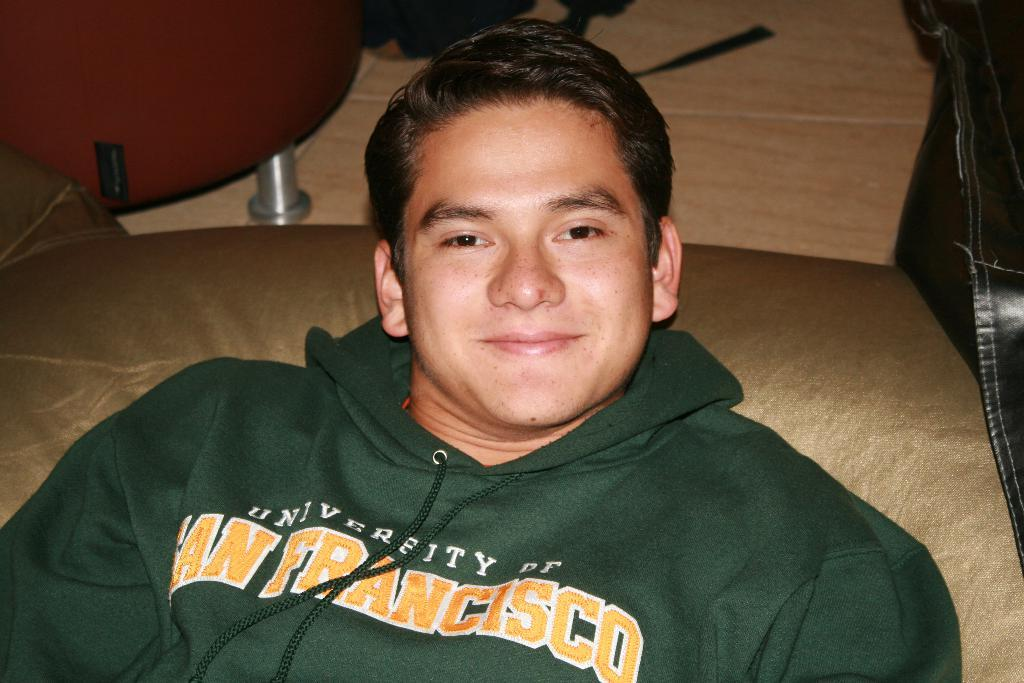<image>
Share a concise interpretation of the image provided. a person with a green sweater with san francisco on it 